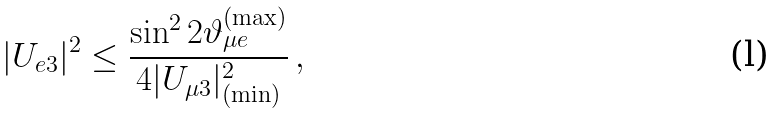<formula> <loc_0><loc_0><loc_500><loc_500>| U _ { e 3 } | ^ { 2 } \leq \frac { \sin ^ { 2 } 2 \vartheta _ { \mu { e } } ^ { ( \max ) } } { 4 | U _ { \mu 3 } | ^ { 2 } _ { ( \min ) } } \, ,</formula> 